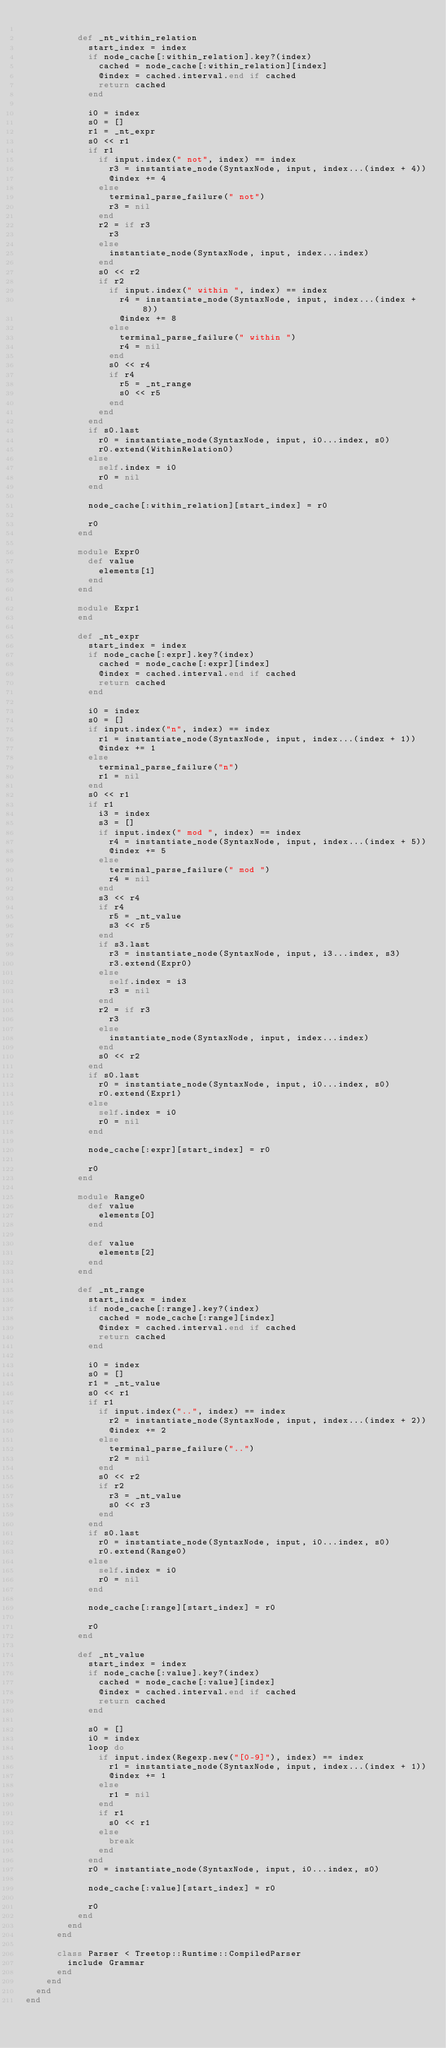<code> <loc_0><loc_0><loc_500><loc_500><_Ruby_>
          def _nt_within_relation
            start_index = index
            if node_cache[:within_relation].key?(index)
              cached = node_cache[:within_relation][index]
              @index = cached.interval.end if cached
              return cached
            end

            i0 = index
            s0 = []
            r1 = _nt_expr
            s0 << r1
            if r1
              if input.index(" not", index) == index
                r3 = instantiate_node(SyntaxNode, input, index...(index + 4))
                @index += 4
              else
                terminal_parse_failure(" not")
                r3 = nil
              end
              r2 = if r3
                r3
              else
                instantiate_node(SyntaxNode, input, index...index)
              end
              s0 << r2
              if r2
                if input.index(" within ", index) == index
                  r4 = instantiate_node(SyntaxNode, input, index...(index + 8))
                  @index += 8
                else
                  terminal_parse_failure(" within ")
                  r4 = nil
                end
                s0 << r4
                if r4
                  r5 = _nt_range
                  s0 << r5
                end
              end
            end
            if s0.last
              r0 = instantiate_node(SyntaxNode, input, i0...index, s0)
              r0.extend(WithinRelation0)
            else
              self.index = i0
              r0 = nil
            end

            node_cache[:within_relation][start_index] = r0

            r0
          end

          module Expr0
            def value
              elements[1]
            end
          end

          module Expr1
          end

          def _nt_expr
            start_index = index
            if node_cache[:expr].key?(index)
              cached = node_cache[:expr][index]
              @index = cached.interval.end if cached
              return cached
            end

            i0 = index
            s0 = []
            if input.index("n", index) == index
              r1 = instantiate_node(SyntaxNode, input, index...(index + 1))
              @index += 1
            else
              terminal_parse_failure("n")
              r1 = nil
            end
            s0 << r1
            if r1
              i3 = index
              s3 = []
              if input.index(" mod ", index) == index
                r4 = instantiate_node(SyntaxNode, input, index...(index + 5))
                @index += 5
              else
                terminal_parse_failure(" mod ")
                r4 = nil
              end
              s3 << r4
              if r4
                r5 = _nt_value
                s3 << r5
              end
              if s3.last
                r3 = instantiate_node(SyntaxNode, input, i3...index, s3)
                r3.extend(Expr0)
              else
                self.index = i3
                r3 = nil
              end
              r2 = if r3
                r3
              else
                instantiate_node(SyntaxNode, input, index...index)
              end
              s0 << r2
            end
            if s0.last
              r0 = instantiate_node(SyntaxNode, input, i0...index, s0)
              r0.extend(Expr1)
            else
              self.index = i0
              r0 = nil
            end

            node_cache[:expr][start_index] = r0

            r0
          end

          module Range0
            def value
              elements[0]
            end

            def value
              elements[2]
            end
          end

          def _nt_range
            start_index = index
            if node_cache[:range].key?(index)
              cached = node_cache[:range][index]
              @index = cached.interval.end if cached
              return cached
            end

            i0 = index
            s0 = []
            r1 = _nt_value
            s0 << r1
            if r1
              if input.index("..", index) == index
                r2 = instantiate_node(SyntaxNode, input, index...(index + 2))
                @index += 2
              else
                terminal_parse_failure("..")
                r2 = nil
              end
              s0 << r2
              if r2
                r3 = _nt_value
                s0 << r3
              end
            end
            if s0.last
              r0 = instantiate_node(SyntaxNode, input, i0...index, s0)
              r0.extend(Range0)
            else
              self.index = i0
              r0 = nil
            end

            node_cache[:range][start_index] = r0

            r0
          end

          def _nt_value
            start_index = index
            if node_cache[:value].key?(index)
              cached = node_cache[:value][index]
              @index = cached.interval.end if cached
              return cached
            end

            s0 = []
            i0 = index
            loop do
              if input.index(Regexp.new("[0-9]"), index) == index
                r1 = instantiate_node(SyntaxNode, input, index...(index + 1))
                @index += 1
              else
                r1 = nil
              end
              if r1
                s0 << r1
              else
                break
              end
            end
            r0 = instantiate_node(SyntaxNode, input, i0...index, s0)

            node_cache[:value][start_index] = r0

            r0
          end
        end
      end

      class Parser < Treetop::Runtime::CompiledParser
        include Grammar
      end
    end
  end
end
</code> 